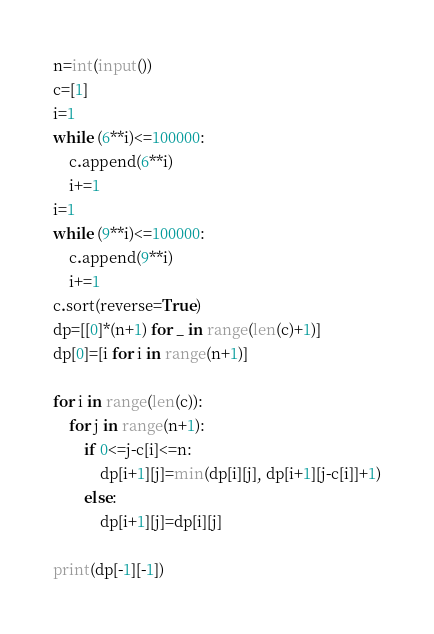<code> <loc_0><loc_0><loc_500><loc_500><_Python_>n=int(input())
c=[1]
i=1
while (6**i)<=100000:
    c.append(6**i)
    i+=1
i=1
while (9**i)<=100000:
    c.append(9**i)
    i+=1
c.sort(reverse=True)
dp=[[0]*(n+1) for _ in range(len(c)+1)]
dp[0]=[i for i in range(n+1)]

for i in range(len(c)):
    for j in range(n+1):
        if 0<=j-c[i]<=n:
            dp[i+1][j]=min(dp[i][j], dp[i+1][j-c[i]]+1)
        else:
            dp[i+1][j]=dp[i][j]

print(dp[-1][-1])</code> 